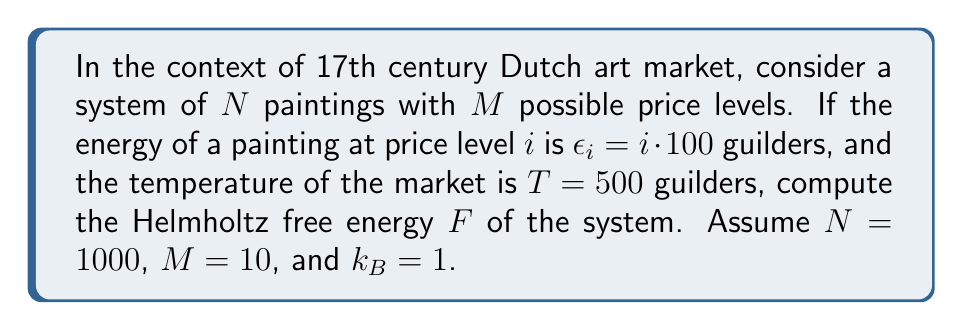Solve this math problem. To compute the Helmholtz free energy $F$, we'll use the formula:

$$F = -k_B T \ln Z$$

where $Z$ is the partition function.

Step 1: Calculate the partition function $Z$.
For a system with $M$ energy levels, the partition function is:

$$Z = \sum_{i=1}^M e^{-\beta \epsilon_i}$$

where $\beta = \frac{1}{k_B T}$.

Step 2: Calculate $\beta$.
$$\beta = \frac{1}{k_B T} = \frac{1}{1 \cdot 500} = 0.002$$

Step 3: Calculate each term in the sum for $Z$.
$$e^{-\beta \epsilon_i} = e^{-0.002 \cdot i \cdot 100} = e^{-0.2i}$$

Step 4: Sum up all terms to get $Z$.
$$Z = \sum_{i=1}^{10} e^{-0.2i} = 5.2456$$

Step 5: Calculate the free energy $F$.
$$F = -k_B T \ln Z$$
$$F = -1 \cdot 500 \cdot \ln(5.2456)$$
$$F = -831.7 \text{ guilders}$$

Step 6: Multiply by $N$ to get the total free energy of the system.
$$F_{\text{total}} = N \cdot F = 1000 \cdot (-831.7) = -831,700 \text{ guilders}$$
Answer: $-831,700$ guilders 